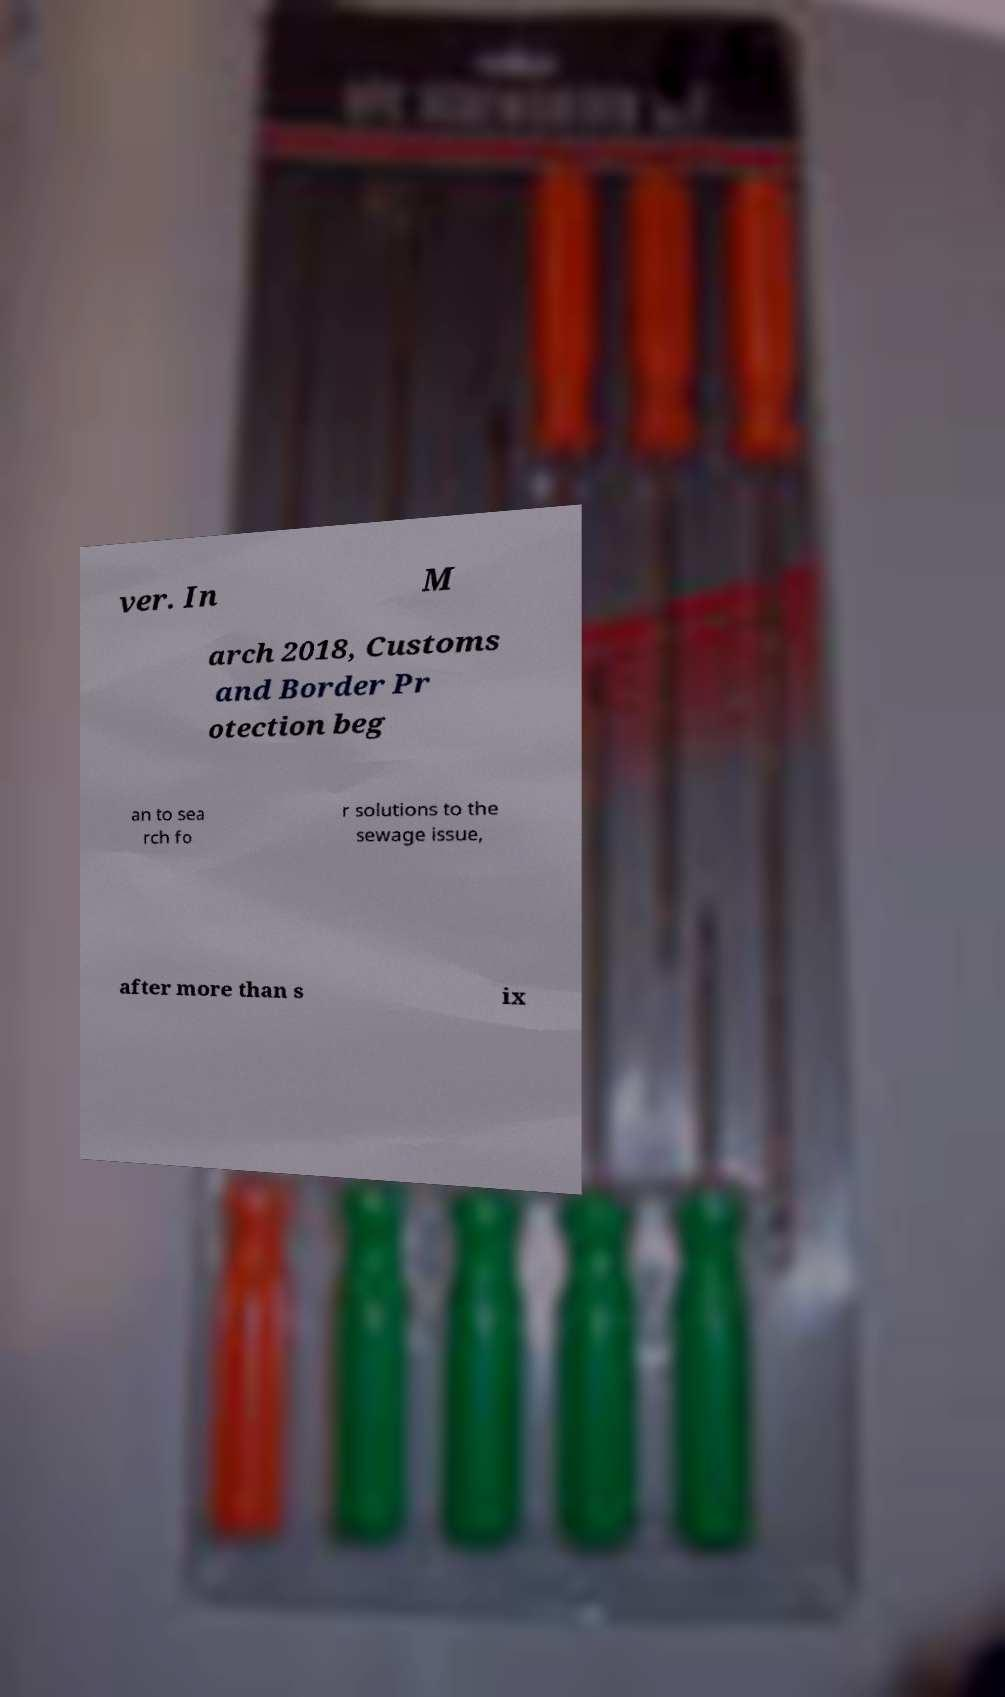Please identify and transcribe the text found in this image. ver. In M arch 2018, Customs and Border Pr otection beg an to sea rch fo r solutions to the sewage issue, after more than s ix 